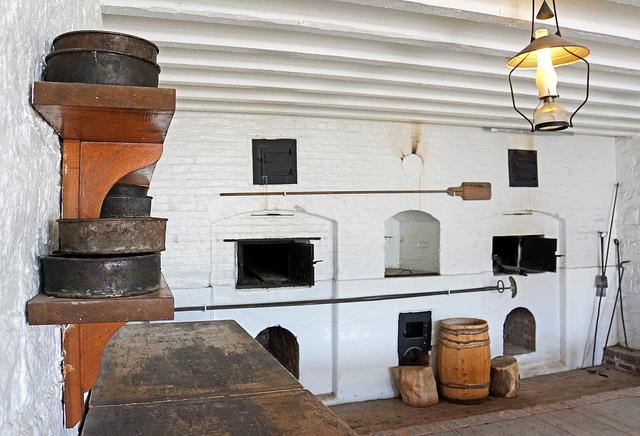Is this a modern kitchen?
Give a very brief answer. No. Are there any people?
Keep it brief. No. What was this room used for baking?
Write a very short answer. Yes. 